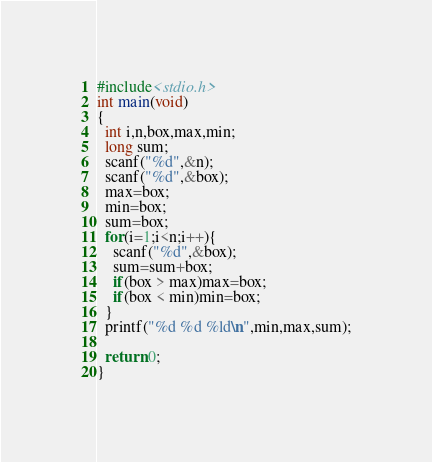Convert code to text. <code><loc_0><loc_0><loc_500><loc_500><_C_>#include<stdio.h>
int main(void)
{
  int i,n,box,max,min;
  long sum;
  scanf("%d",&n);
  scanf("%d",&box);
  max=box;
  min=box;
  sum=box;
  for(i=1;i<n;i++){
    scanf("%d",&box);
    sum=sum+box;
    if(box > max)max=box;
    if(box < min)min=box;
  }
  printf("%d %d %ld\n",min,max,sum);

  return 0;
}</code> 